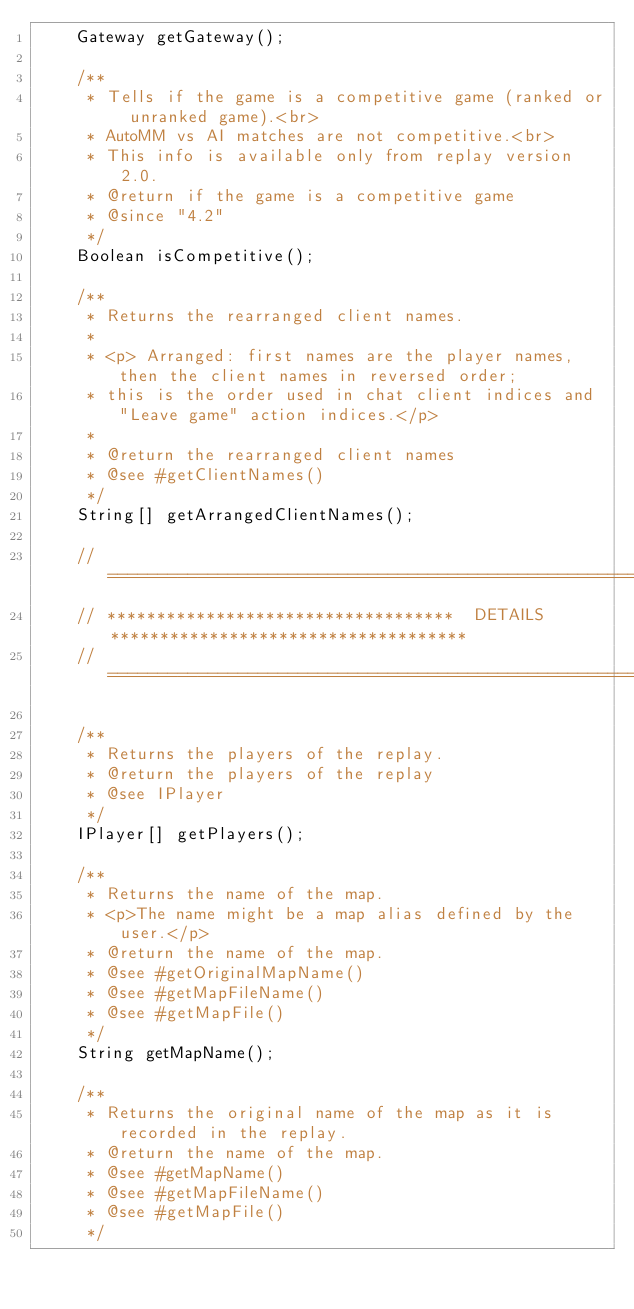<code> <loc_0><loc_0><loc_500><loc_500><_Java_>	Gateway getGateway();
	
	/**
	 * Tells if the game is a competitive game (ranked or unranked game).<br>
	 * AutoMM vs AI matches are not competitive.<br>
	 * This info is available only from replay version 2.0.
	 * @return if the game is a competitive game
	 * @since "4.2"
	 */
	Boolean isCompetitive();
	
	/**
	 * Returns the rearranged client names.
	 * 
	 * <p> Arranged: first names are the player names, then the client names in reversed order;
	 * this is the order used in chat client indices and "Leave game" action indices.</p>
	 * 
	 * @return the rearranged client names
	 * @see #getClientNames()
	 */
	String[] getArrangedClientNames();
	
	// ==================================================================================
	// ***********************************  DETAILS  ************************************
	// ==================================================================================
	
	/**
	 * Returns the players of the replay.
	 * @return the players of the replay
	 * @see IPlayer
	 */
	IPlayer[] getPlayers();
	
	/**
	 * Returns the name of the map.
	 * <p>The name might be a map alias defined by the user.</p>
	 * @return the name of the map.
	 * @see #getOriginalMapName()
	 * @see #getMapFileName()
	 * @see #getMapFile()
	 */
	String getMapName();
	
	/**
	 * Returns the original name of the map as it is recorded in the replay.
	 * @return the name of the map.
	 * @see #getMapName()
	 * @see #getMapFileName()
	 * @see #getMapFile()
	 */</code> 